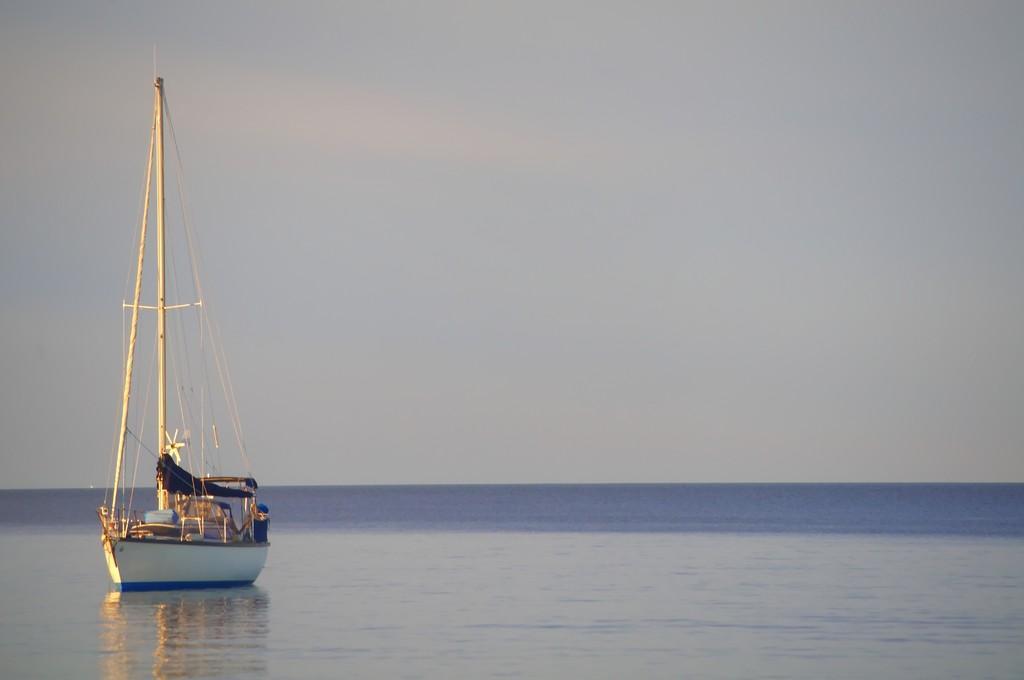Describe this image in one or two sentences. In this picture we can see a boat on water and on this boat we can see some objects and in the background we can see the sky. 